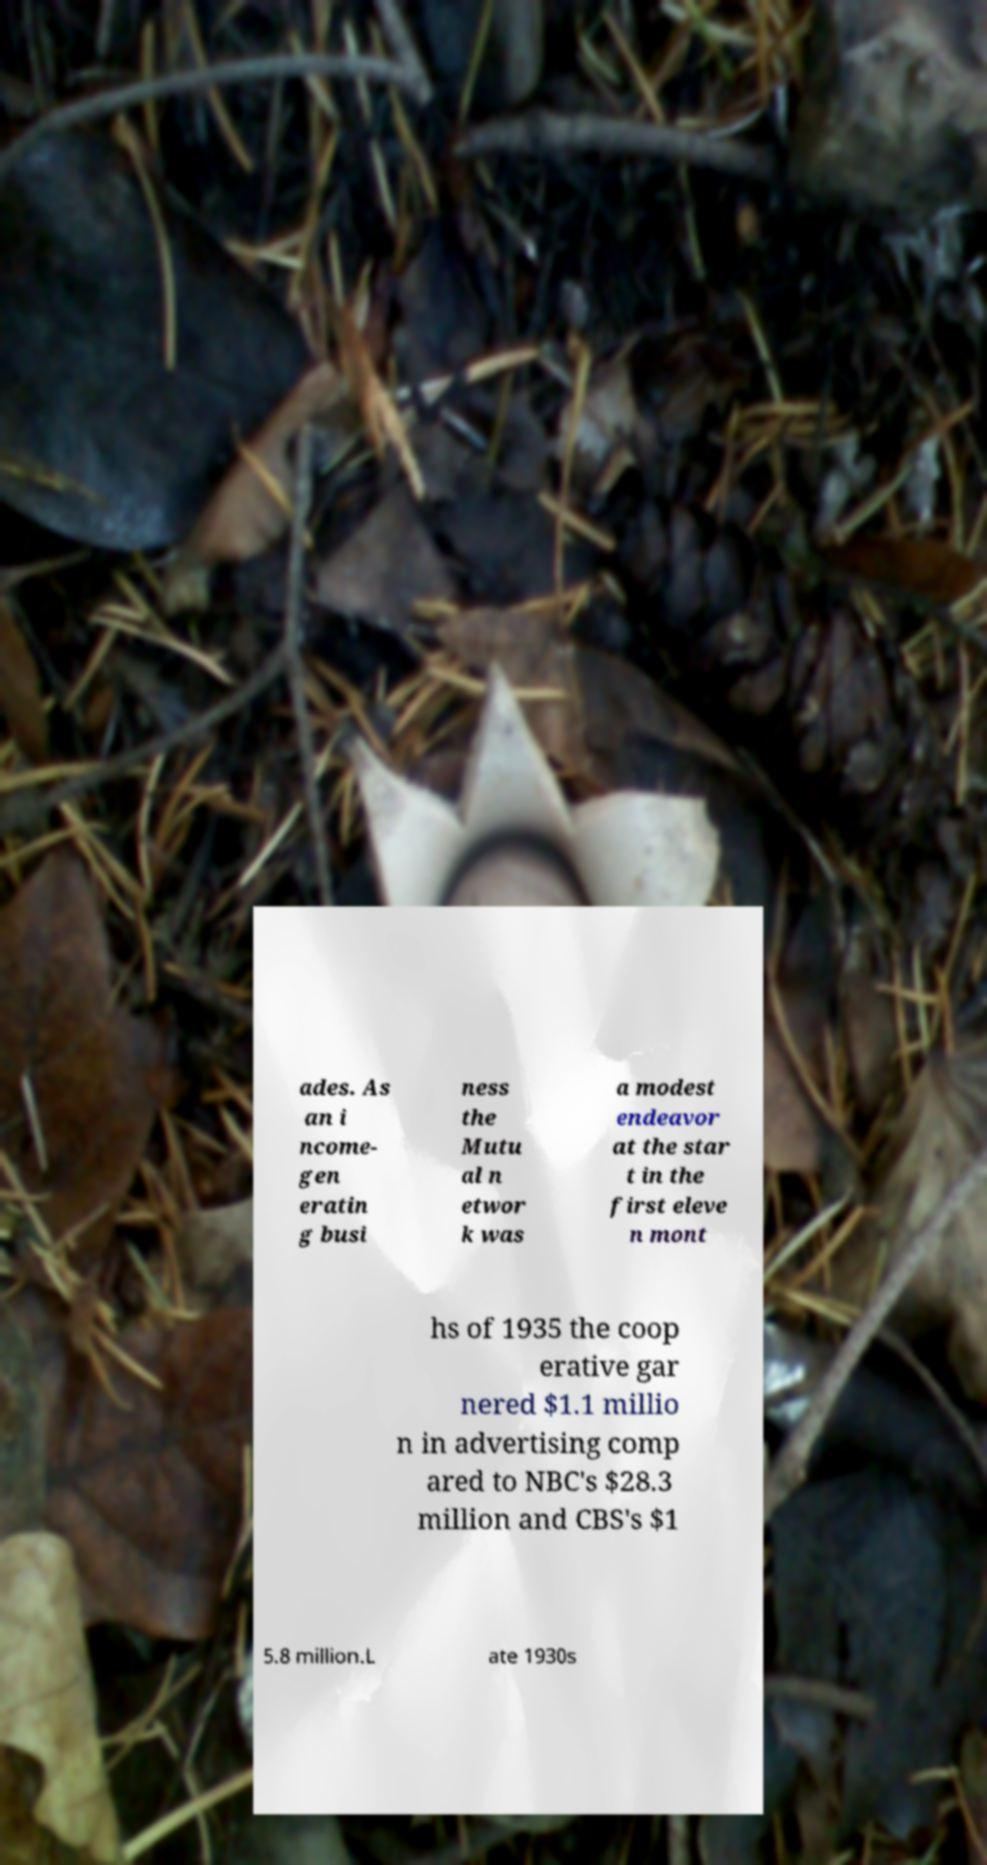Please read and relay the text visible in this image. What does it say? ades. As an i ncome- gen eratin g busi ness the Mutu al n etwor k was a modest endeavor at the star t in the first eleve n mont hs of 1935 the coop erative gar nered $1.1 millio n in advertising comp ared to NBC's $28.3 million and CBS's $1 5.8 million.L ate 1930s 